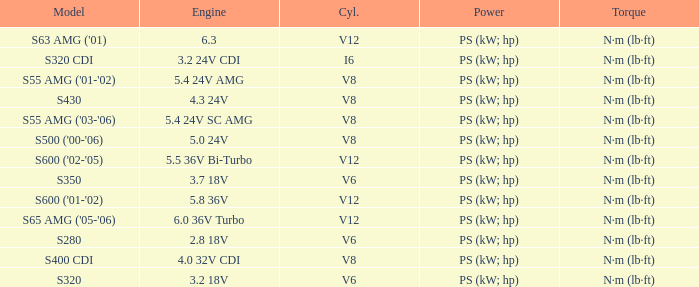Which Engine has a Model of s320 cdi? 3.2 24V CDI. 